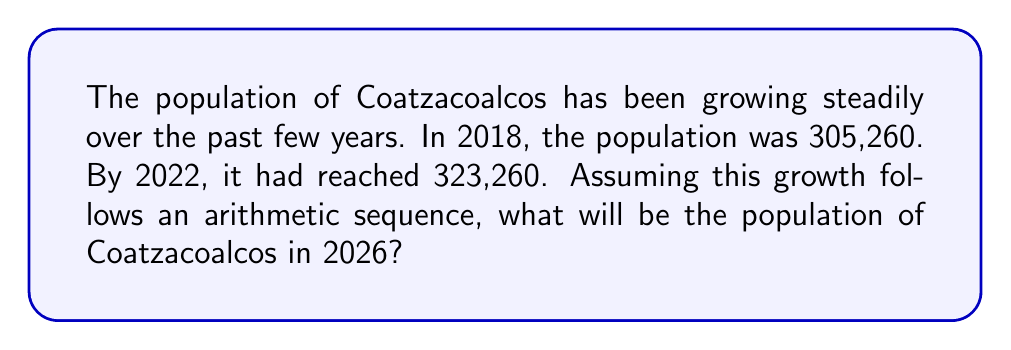Can you solve this math problem? To solve this problem, we need to follow these steps:

1. Identify the arithmetic sequence:
   - First term (2018): $a_1 = 305,260$
   - Fifth term (2022): $a_5 = 323,260$

2. Calculate the common difference (d):
   $$d = \frac{a_5 - a_1}{5 - 1} = \frac{323,260 - 305,260}{4} = 4,500$$

3. Use the arithmetic sequence formula to find the 9th term (2026):
   $$a_n = a_1 + (n - 1)d$$
   $$a_9 = 305,260 + (9 - 1)(4,500)$$
   $$a_9 = 305,260 + (8)(4,500)$$
   $$a_9 = 305,260 + 36,000$$
   $$a_9 = 341,260$$

Therefore, the population of Coatzacoalcos in 2026 will be 341,260.
Answer: 341,260 